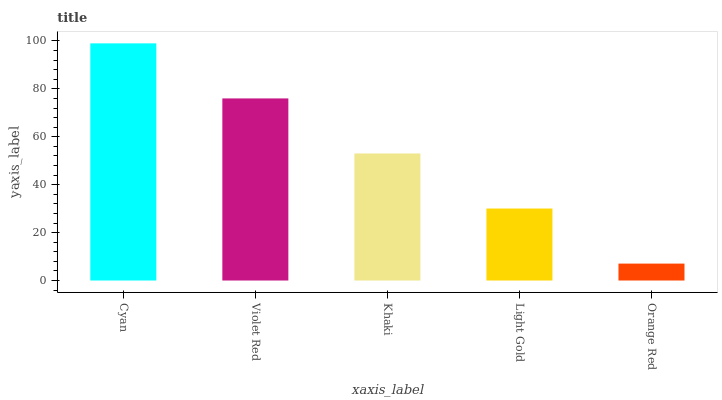Is Orange Red the minimum?
Answer yes or no. Yes. Is Cyan the maximum?
Answer yes or no. Yes. Is Violet Red the minimum?
Answer yes or no. No. Is Violet Red the maximum?
Answer yes or no. No. Is Cyan greater than Violet Red?
Answer yes or no. Yes. Is Violet Red less than Cyan?
Answer yes or no. Yes. Is Violet Red greater than Cyan?
Answer yes or no. No. Is Cyan less than Violet Red?
Answer yes or no. No. Is Khaki the high median?
Answer yes or no. Yes. Is Khaki the low median?
Answer yes or no. Yes. Is Cyan the high median?
Answer yes or no. No. Is Cyan the low median?
Answer yes or no. No. 